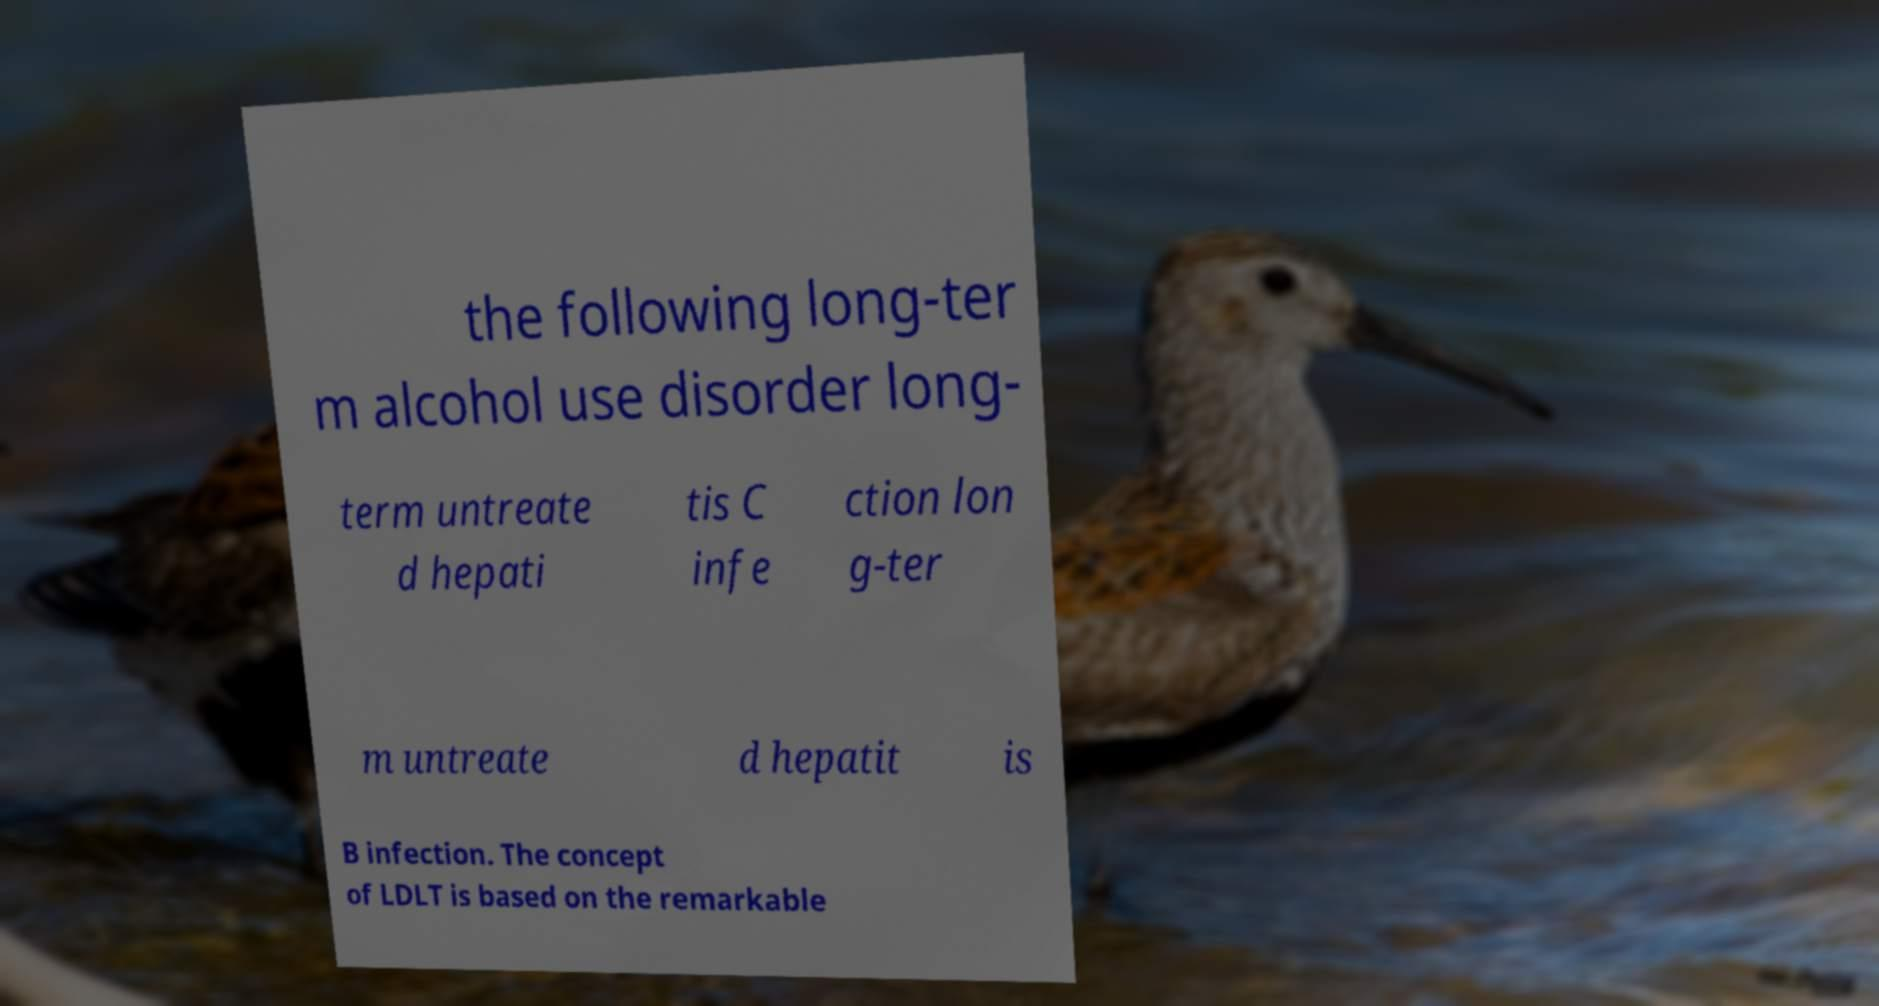Please identify and transcribe the text found in this image. the following long-ter m alcohol use disorder long- term untreate d hepati tis C infe ction lon g-ter m untreate d hepatit is B infection. The concept of LDLT is based on the remarkable 